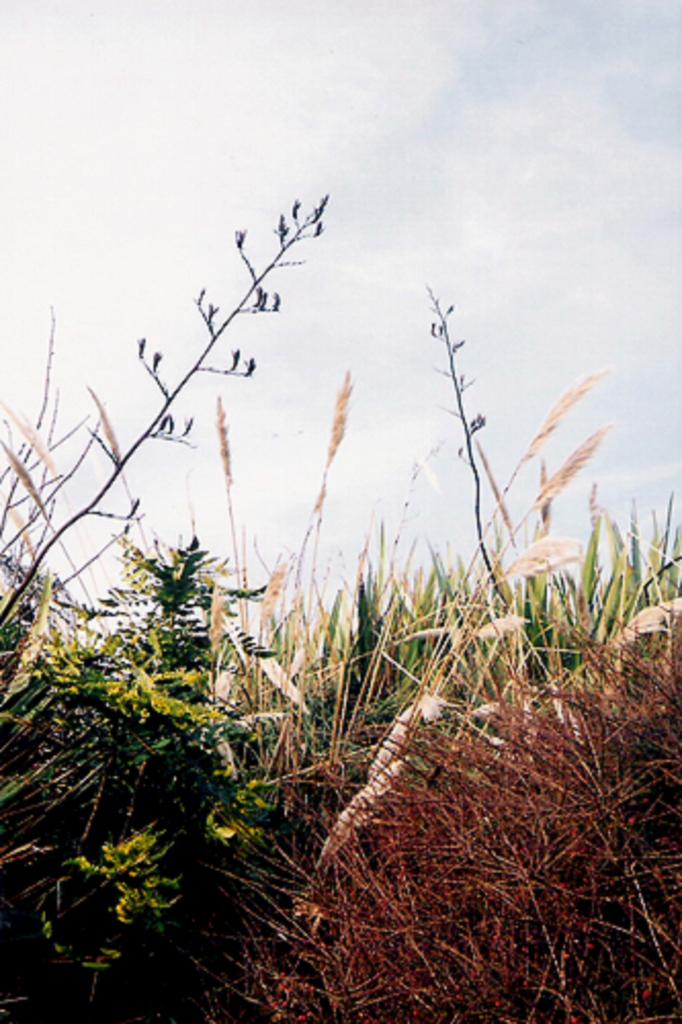What type of living organisms can be seen in the image? Plants can be seen in the image. What part of the natural environment is visible in the image? The sky is visible in the background of the image. What type of coat is the geese wearing in the image? There are no geese or coats present in the image. How comfortable are the plants in the image? The comfort level of the plants cannot be determined from the image. 